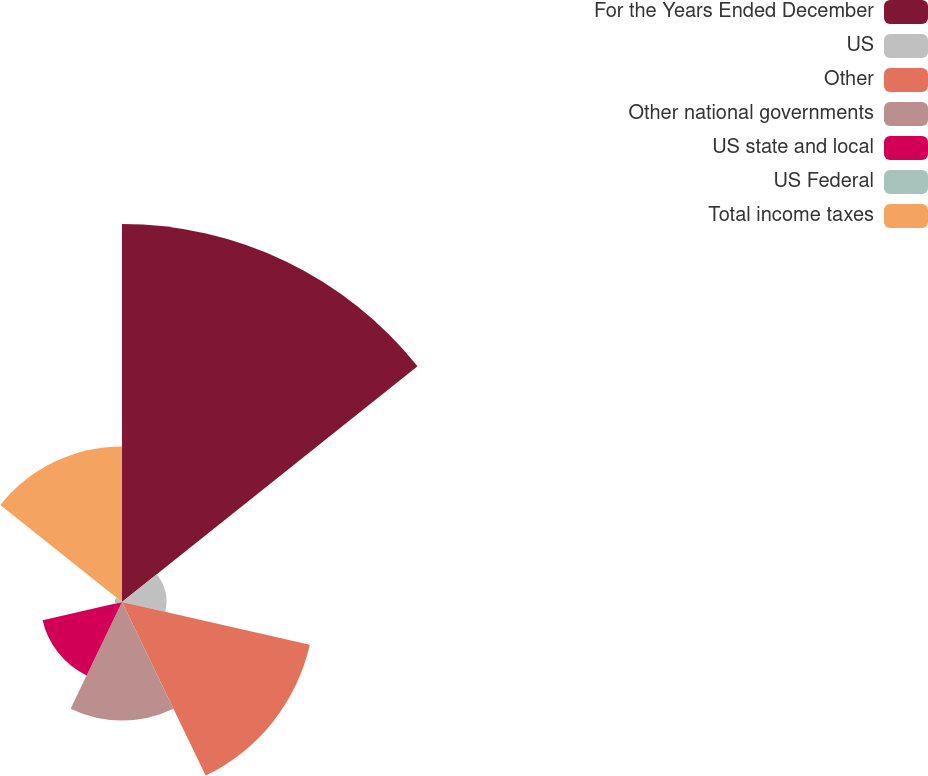Convert chart to OTSL. <chart><loc_0><loc_0><loc_500><loc_500><pie_chart><fcel>For the Years Ended December<fcel>US<fcel>Other<fcel>Other national governments<fcel>US state and local<fcel>US Federal<fcel>Total income taxes<nl><fcel>38.65%<fcel>4.54%<fcel>19.7%<fcel>12.12%<fcel>8.33%<fcel>0.75%<fcel>15.91%<nl></chart> 